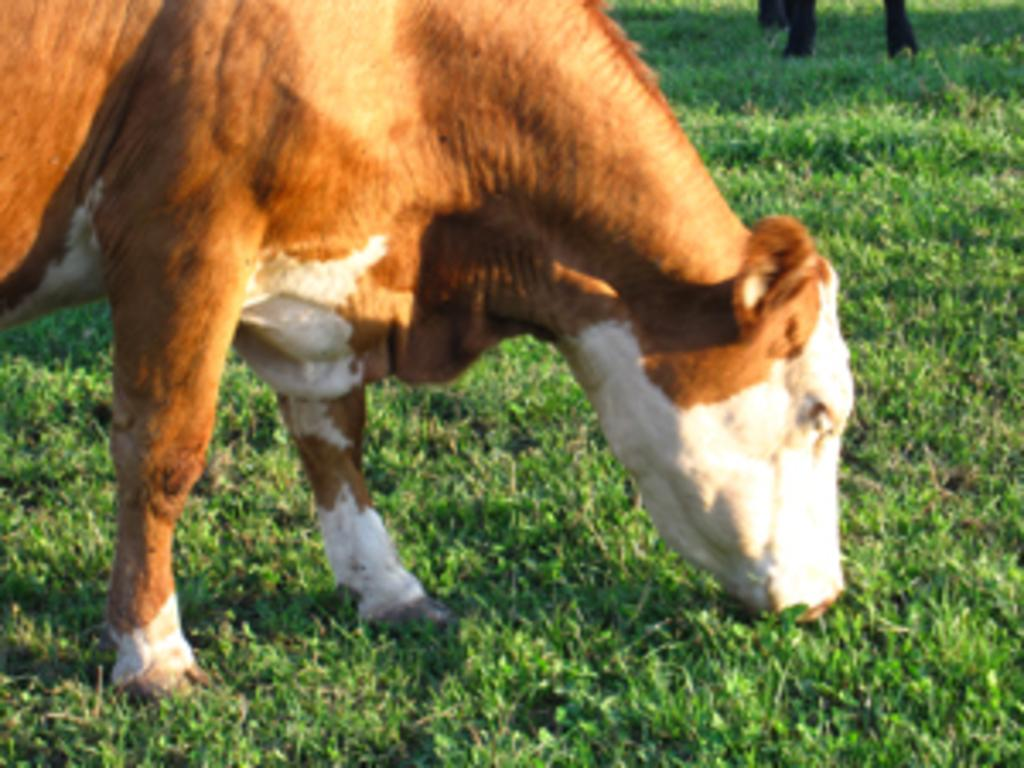How many cows are present in the image? There are two cows in the image. What is the cows' location in the image? The cows are standing on the grass. Can you describe the time of day when the image was taken? The image appears to be taken during the day. What type of kite is the daughter flying in the image? There is no kite or daughter present in the image; it features two cows standing on the grass. 